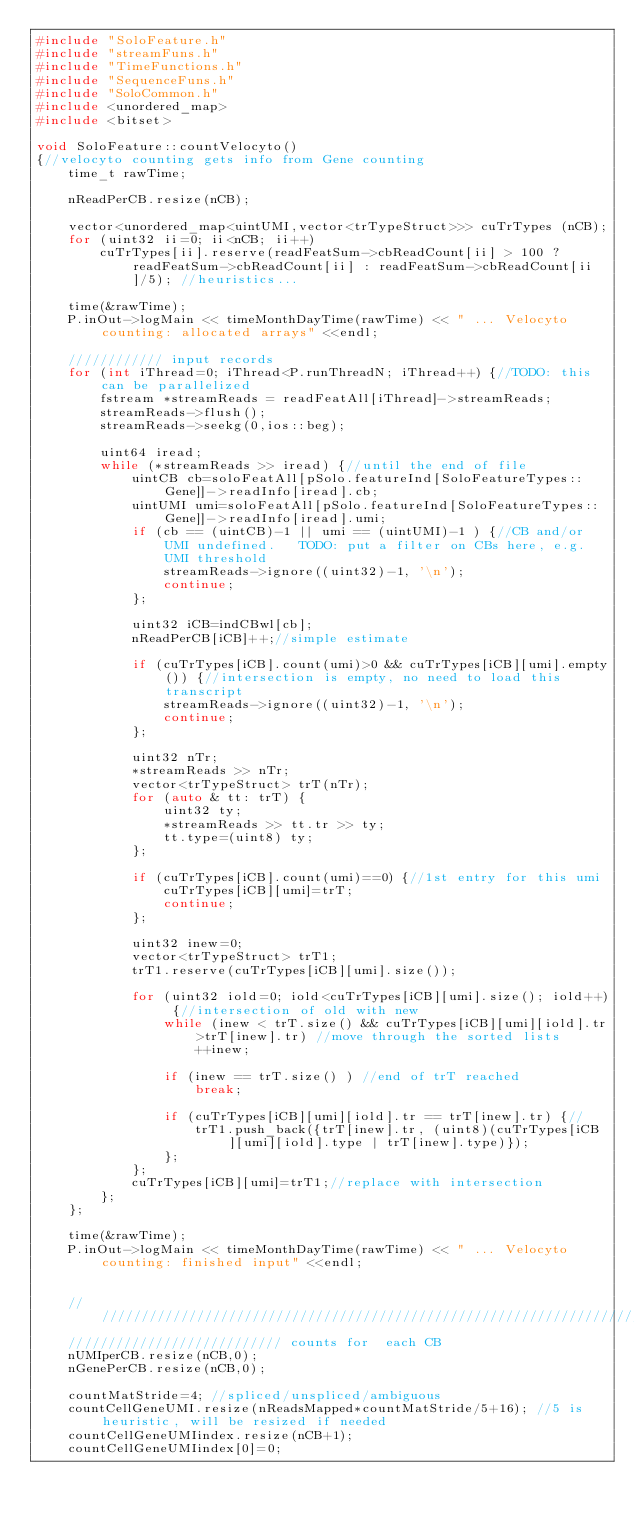Convert code to text. <code><loc_0><loc_0><loc_500><loc_500><_C++_>#include "SoloFeature.h"
#include "streamFuns.h"
#include "TimeFunctions.h"
#include "SequenceFuns.h"
#include "SoloCommon.h"
#include <unordered_map>
#include <bitset>

void SoloFeature::countVelocyto()
{//velocyto counting gets info from Gene counting
    time_t rawTime;

    nReadPerCB.resize(nCB);

    vector<unordered_map<uintUMI,vector<trTypeStruct>>> cuTrTypes (nCB);
    for (uint32 ii=0; ii<nCB; ii++)
        cuTrTypes[ii].reserve(readFeatSum->cbReadCount[ii] > 100 ? readFeatSum->cbReadCount[ii] : readFeatSum->cbReadCount[ii]/5); //heuristics...
    
    time(&rawTime);
    P.inOut->logMain << timeMonthDayTime(rawTime) << " ... Velocyto counting: allocated arrays" <<endl;
    
    //////////// input records
    for (int iThread=0; iThread<P.runThreadN; iThread++) {//TODO: this can be parallelized
        fstream *streamReads = readFeatAll[iThread]->streamReads;
        streamReads->flush();
        streamReads->seekg(0,ios::beg);
        
        uint64 iread;
        while (*streamReads >> iread) {//until the end of file
            uintCB cb=soloFeatAll[pSolo.featureInd[SoloFeatureTypes::Gene]]->readInfo[iread].cb;
            uintUMI umi=soloFeatAll[pSolo.featureInd[SoloFeatureTypes::Gene]]->readInfo[iread].umi;
            if (cb == (uintCB)-1 || umi == (uintUMI)-1 ) {//CB and/or UMI undefined.   TODO: put a filter on CBs here, e.g. UMI threshold
                streamReads->ignore((uint32)-1, '\n');
                continue;
            };

            uint32 iCB=indCBwl[cb];
            nReadPerCB[iCB]++;//simple estimate
            
            if (cuTrTypes[iCB].count(umi)>0 && cuTrTypes[iCB][umi].empty()) {//intersection is empty, no need to load this transcript
                streamReads->ignore((uint32)-1, '\n');
                continue;
            };

            uint32 nTr;
            *streamReads >> nTr;
            vector<trTypeStruct> trT(nTr);
            for (auto & tt: trT) {
                uint32 ty;
                *streamReads >> tt.tr >> ty;
                tt.type=(uint8) ty;
            };

            if (cuTrTypes[iCB].count(umi)==0) {//1st entry for this umi
                cuTrTypes[iCB][umi]=trT;
                continue;
            };
            
            uint32 inew=0;
            vector<trTypeStruct> trT1;
            trT1.reserve(cuTrTypes[iCB][umi].size());
            
            for (uint32 iold=0; iold<cuTrTypes[iCB][umi].size(); iold++) {//intersection of old with new
                while (inew < trT.size() && cuTrTypes[iCB][umi][iold].tr>trT[inew].tr) //move through the sorted lists
                    ++inew;
                
                if (inew == trT.size() ) //end of trT reached
                    break;
                
                if (cuTrTypes[iCB][umi][iold].tr == trT[inew].tr) {//
                    trT1.push_back({trT[inew].tr, (uint8)(cuTrTypes[iCB][umi][iold].type | trT[inew].type)});
                };
            };
            cuTrTypes[iCB][umi]=trT1;//replace with intersection
        };        
    };   
    
    time(&rawTime);
    P.inOut->logMain << timeMonthDayTime(rawTime) << " ... Velocyto counting: finished input" <<endl;

    
    //////////////////////////////////////////////////////////////////////////////
    /////////////////////////// counts for  each CB
    nUMIperCB.resize(nCB,0);
    nGenePerCB.resize(nCB,0);
       
    countMatStride=4; //spliced/unspliced/ambiguous
    countCellGeneUMI.resize(nReadsMapped*countMatStride/5+16); //5 is heuristic, will be resized if needed
    countCellGeneUMIindex.resize(nCB+1);
    countCellGeneUMIindex[0]=0;
    </code> 